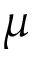<formula> <loc_0><loc_0><loc_500><loc_500>\mu</formula> 